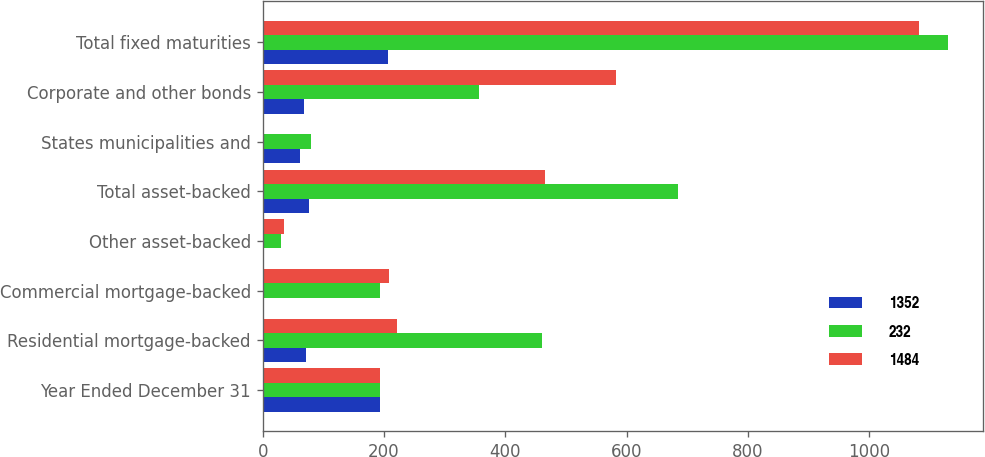Convert chart. <chart><loc_0><loc_0><loc_500><loc_500><stacked_bar_chart><ecel><fcel>Year Ended December 31<fcel>Residential mortgage-backed<fcel>Commercial mortgage-backed<fcel>Other asset-backed<fcel>Total asset-backed<fcel>States municipalities and<fcel>Corporate and other bonds<fcel>Total fixed maturities<nl><fcel>1352<fcel>193<fcel>71<fcel>3<fcel>3<fcel>77<fcel>62<fcel>68<fcel>207<nl><fcel>232<fcel>193<fcel>461<fcel>193<fcel>31<fcel>685<fcel>79<fcel>357<fcel>1130<nl><fcel>1484<fcel>193<fcel>222<fcel>208<fcel>35<fcel>465<fcel>1<fcel>583<fcel>1081<nl></chart> 